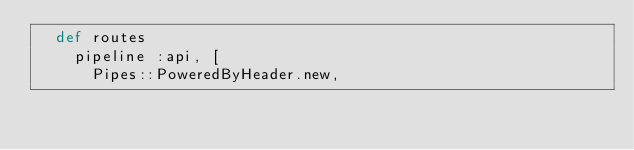Convert code to text. <code><loc_0><loc_0><loc_500><loc_500><_Crystal_>  def routes
    pipeline :api, [
      Pipes::PoweredByHeader.new,</code> 